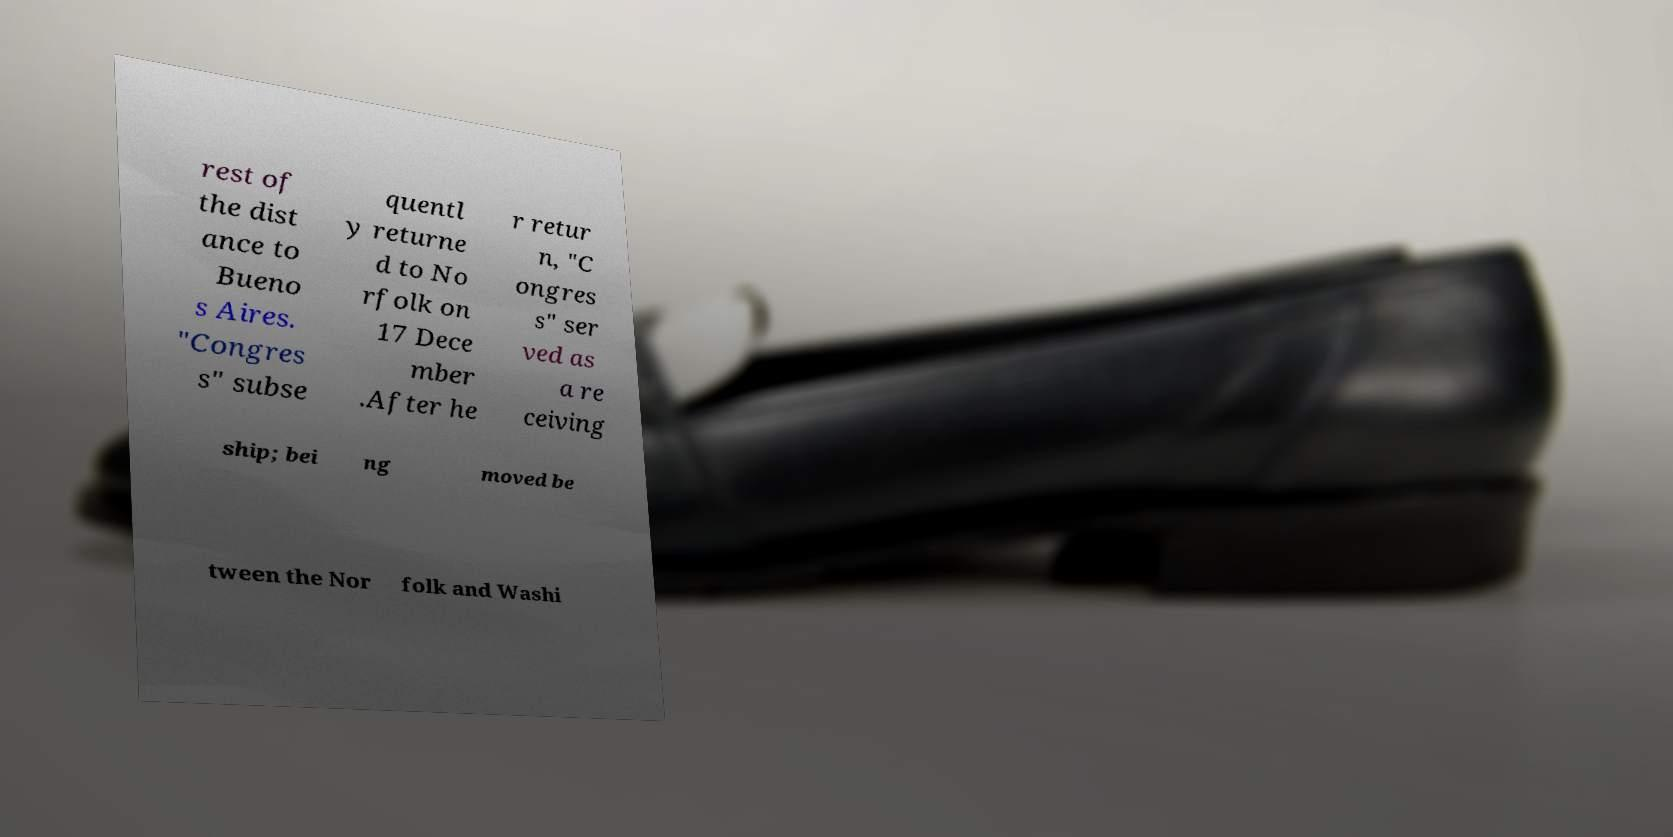For documentation purposes, I need the text within this image transcribed. Could you provide that? rest of the dist ance to Bueno s Aires. "Congres s" subse quentl y returne d to No rfolk on 17 Dece mber .After he r retur n, "C ongres s" ser ved as a re ceiving ship; bei ng moved be tween the Nor folk and Washi 